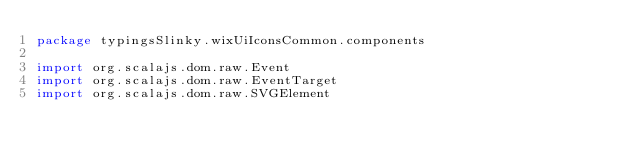Convert code to text. <code><loc_0><loc_0><loc_500><loc_500><_Scala_>package typingsSlinky.wixUiIconsCommon.components

import org.scalajs.dom.raw.Event
import org.scalajs.dom.raw.EventTarget
import org.scalajs.dom.raw.SVGElement</code> 